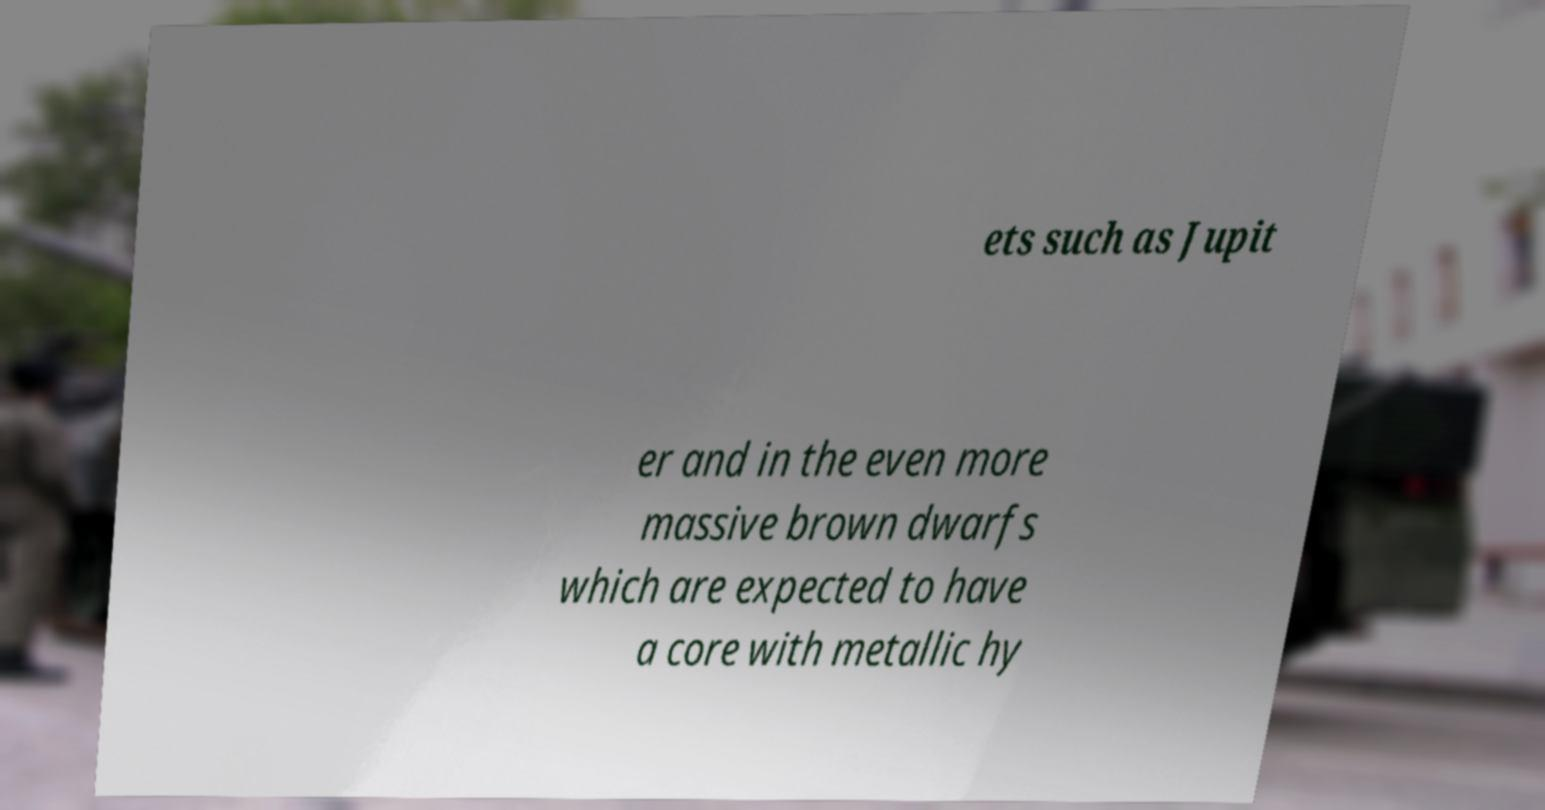Can you read and provide the text displayed in the image?This photo seems to have some interesting text. Can you extract and type it out for me? ets such as Jupit er and in the even more massive brown dwarfs which are expected to have a core with metallic hy 